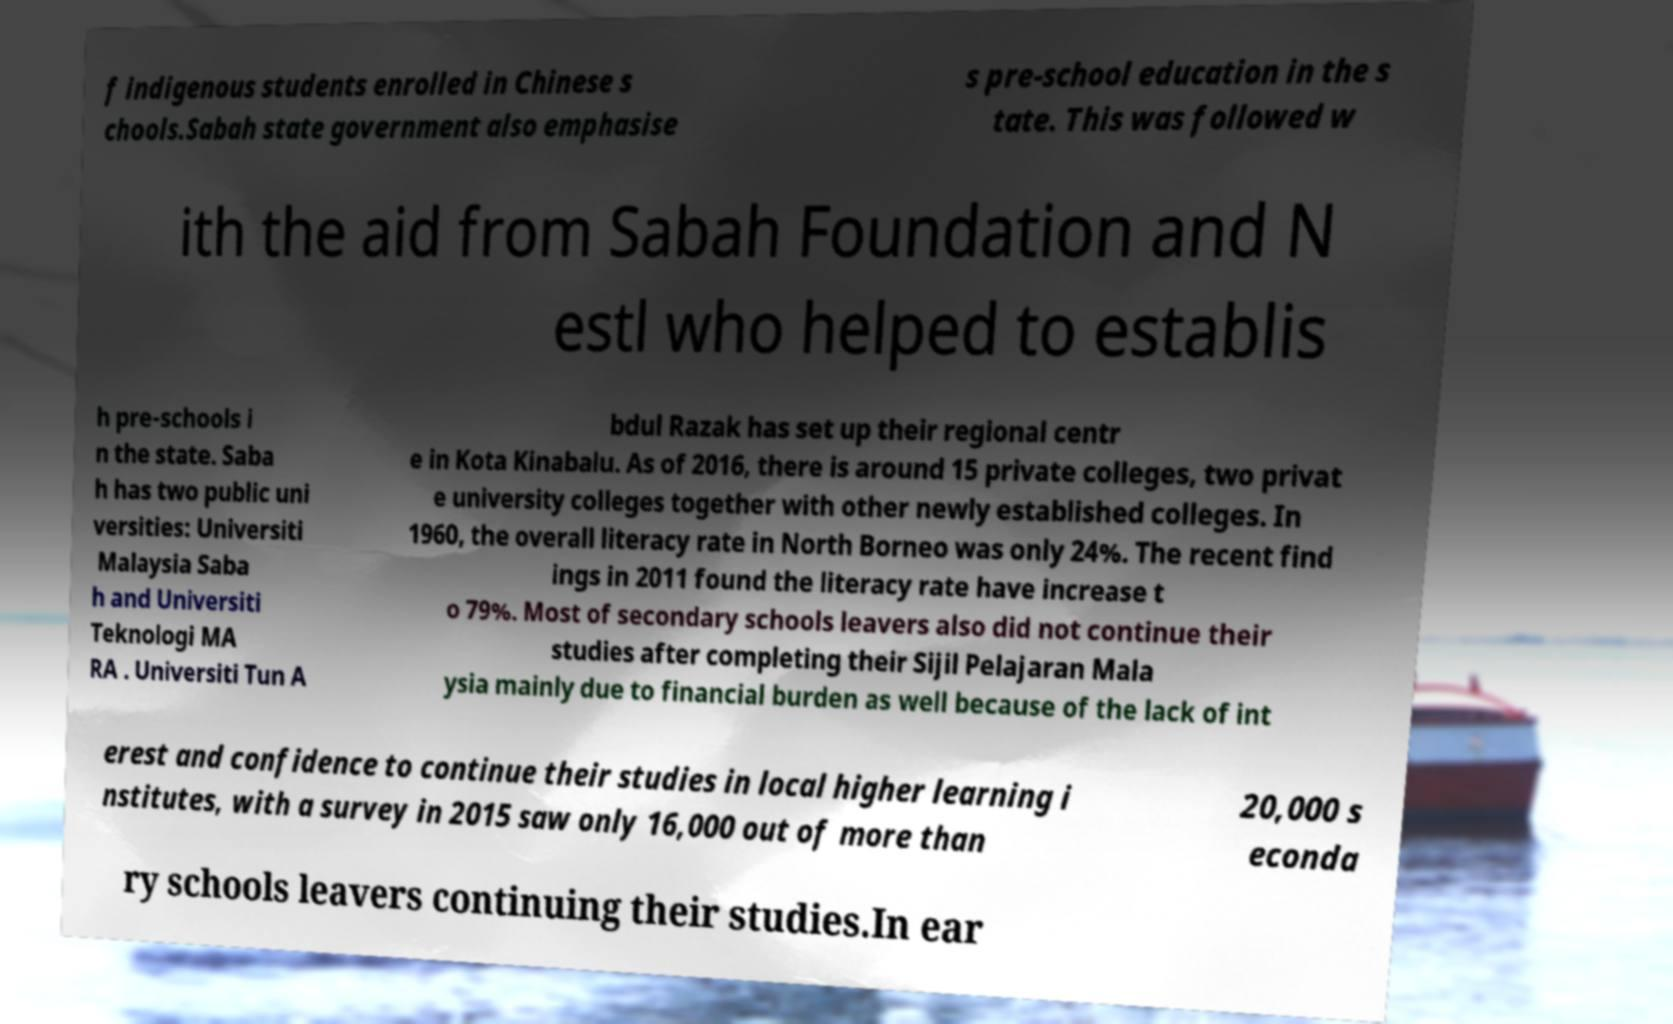What messages or text are displayed in this image? I need them in a readable, typed format. f indigenous students enrolled in Chinese s chools.Sabah state government also emphasise s pre-school education in the s tate. This was followed w ith the aid from Sabah Foundation and N estl who helped to establis h pre-schools i n the state. Saba h has two public uni versities: Universiti Malaysia Saba h and Universiti Teknologi MA RA . Universiti Tun A bdul Razak has set up their regional centr e in Kota Kinabalu. As of 2016, there is around 15 private colleges, two privat e university colleges together with other newly established colleges. In 1960, the overall literacy rate in North Borneo was only 24%. The recent find ings in 2011 found the literacy rate have increase t o 79%. Most of secondary schools leavers also did not continue their studies after completing their Sijil Pelajaran Mala ysia mainly due to financial burden as well because of the lack of int erest and confidence to continue their studies in local higher learning i nstitutes, with a survey in 2015 saw only 16,000 out of more than 20,000 s econda ry schools leavers continuing their studies.In ear 